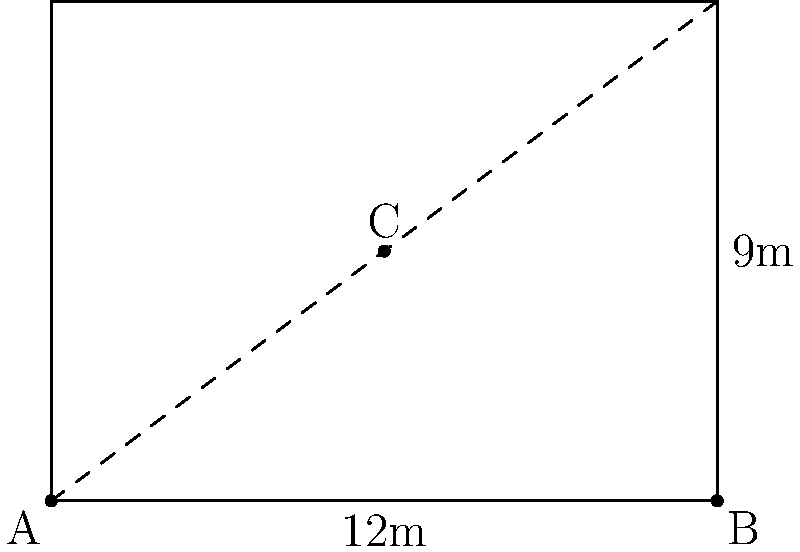During a Kathak performance on a rectangular stage, dancer A is positioned at the bottom-left corner, and dancer C is at the center. If the stage is 12 meters wide and 9 meters deep, what is the distance between dancers A and C? To solve this problem, we can use the Pythagorean theorem. Let's break it down step-by-step:

1. Identify the right triangle:
   The line connecting dancers A and C forms the hypotenuse of a right triangle.

2. Find the lengths of the other two sides:
   - The width of half the stage is 6 meters (12m ÷ 2)
   - The depth of half the stage is 4.5 meters (9m ÷ 2)

3. Apply the Pythagorean theorem:
   $a^2 + b^2 = c^2$
   Where $a$ and $b$ are the lengths of the two sides, and $c$ is the hypotenuse.

4. Substitute the values:
   $6^2 + 4.5^2 = c^2$

5. Calculate:
   $36 + 20.25 = c^2$
   $56.25 = c^2$

6. Take the square root of both sides:
   $\sqrt{56.25} = c$

7. Simplify:
   $c = 7.5$ meters

Therefore, the distance between dancers A and C is 7.5 meters.
Answer: 7.5 meters 